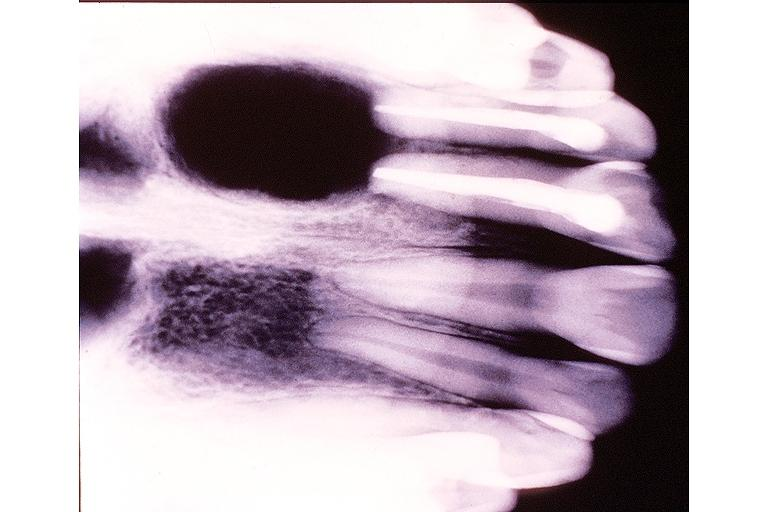what is present?
Answer the question using a single word or phrase. Oral 